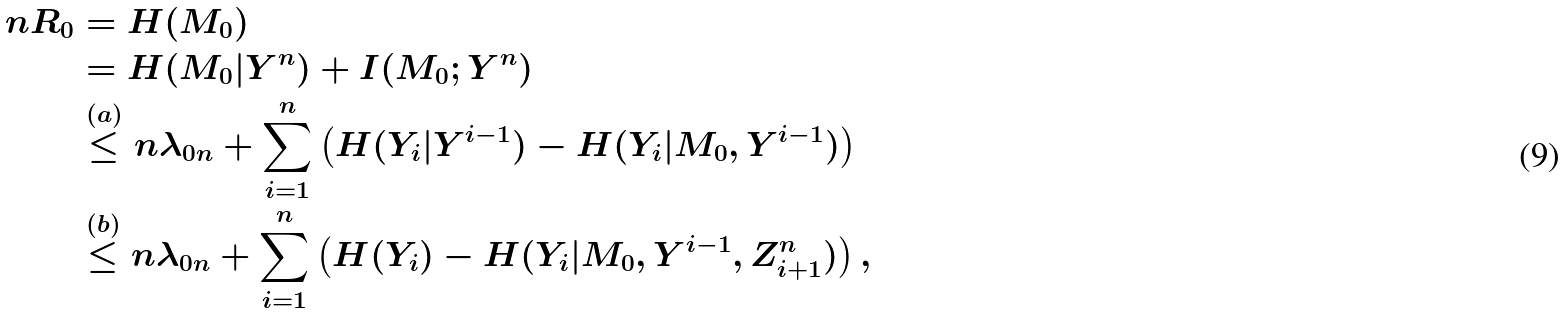<formula> <loc_0><loc_0><loc_500><loc_500>n R _ { 0 } & = H ( M _ { 0 } ) \\ & = H ( M _ { 0 } | Y ^ { n } ) + I ( M _ { 0 } ; Y ^ { n } ) \\ & \stackrel { ( a ) } { \leq } n \lambda _ { 0 n } + \sum _ { i = 1 } ^ { n } \left ( H ( Y _ { i } | Y ^ { i - 1 } ) - H ( Y _ { i } | M _ { 0 } , Y ^ { i - 1 } ) \right ) \\ & \stackrel { ( b ) } { \leq } n \lambda _ { 0 n } + \sum _ { i = 1 } ^ { n } \left ( H ( Y _ { i } ) - H ( Y _ { i } | M _ { 0 } , Y ^ { i - 1 } , Z _ { i + 1 } ^ { n } ) \right ) ,</formula> 